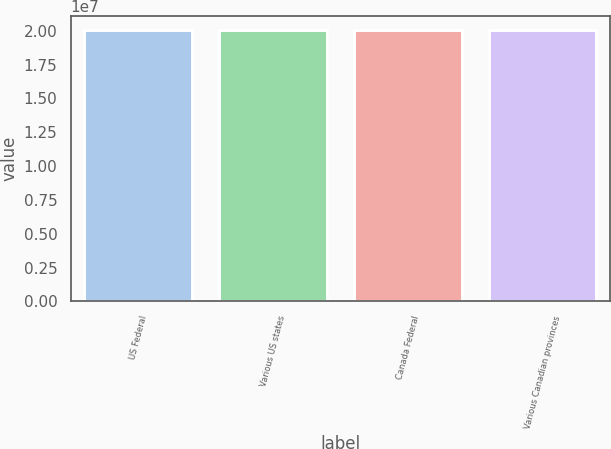Convert chart to OTSL. <chart><loc_0><loc_0><loc_500><loc_500><bar_chart><fcel>US Federal<fcel>Various US states<fcel>Canada Federal<fcel>Various Canadian provinces<nl><fcel>2.0082e+07<fcel>2.0087e+07<fcel>2.0032e+07<fcel>2.0037e+07<nl></chart> 